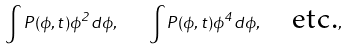<formula> <loc_0><loc_0><loc_500><loc_500>\int P ( \phi , t ) \phi ^ { 2 } d \phi , \quad \int P ( \phi , t ) \phi ^ { 4 } d \phi , \quad \text {etc.} ,</formula> 